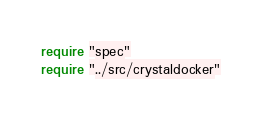<code> <loc_0><loc_0><loc_500><loc_500><_Crystal_>require "spec"
require "../src/crystaldocker"
</code> 